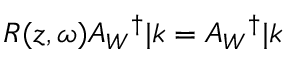<formula> <loc_0><loc_0><loc_500><loc_500>R ( z , \omega ) A _ { W ^ { \dag } | k = A _ { W ^ { \dag } | k</formula> 